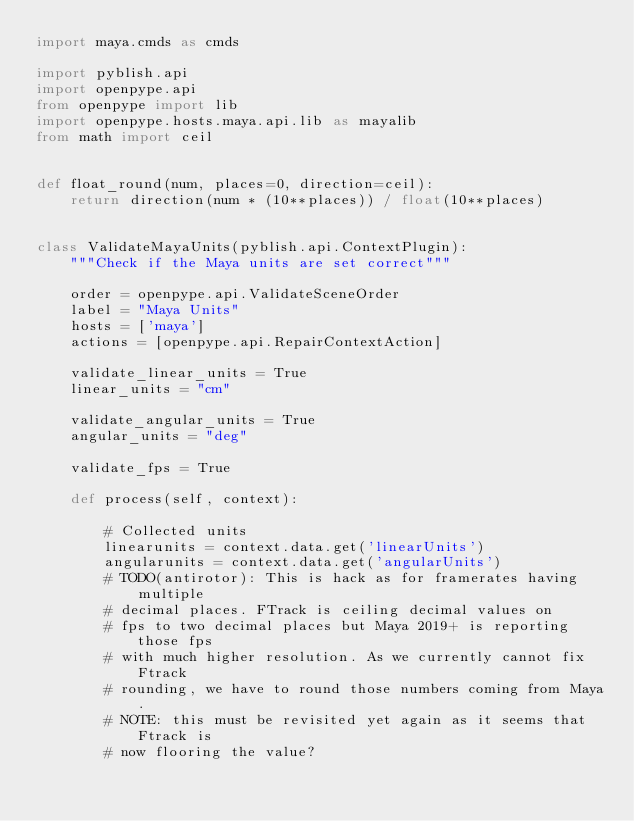Convert code to text. <code><loc_0><loc_0><loc_500><loc_500><_Python_>import maya.cmds as cmds

import pyblish.api
import openpype.api
from openpype import lib
import openpype.hosts.maya.api.lib as mayalib
from math import ceil


def float_round(num, places=0, direction=ceil):
    return direction(num * (10**places)) / float(10**places)


class ValidateMayaUnits(pyblish.api.ContextPlugin):
    """Check if the Maya units are set correct"""

    order = openpype.api.ValidateSceneOrder
    label = "Maya Units"
    hosts = ['maya']
    actions = [openpype.api.RepairContextAction]

    validate_linear_units = True
    linear_units = "cm"

    validate_angular_units = True
    angular_units = "deg"

    validate_fps = True

    def process(self, context):

        # Collected units
        linearunits = context.data.get('linearUnits')
        angularunits = context.data.get('angularUnits')
        # TODO(antirotor): This is hack as for framerates having multiple
        # decimal places. FTrack is ceiling decimal values on
        # fps to two decimal places but Maya 2019+ is reporting those fps
        # with much higher resolution. As we currently cannot fix Ftrack
        # rounding, we have to round those numbers coming from Maya.
        # NOTE: this must be revisited yet again as it seems that Ftrack is
        # now flooring the value?</code> 